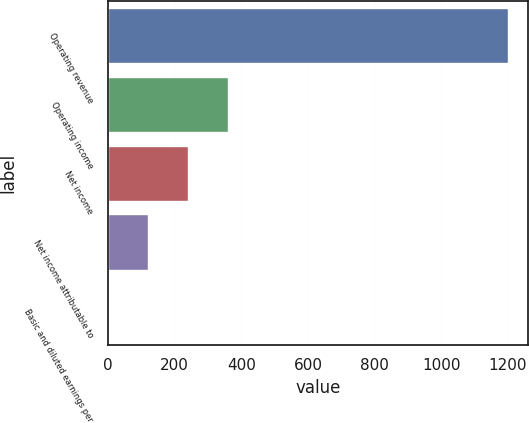Convert chart to OTSL. <chart><loc_0><loc_0><loc_500><loc_500><bar_chart><fcel>Operating revenue<fcel>Operating income<fcel>Net income<fcel>Net income attributable to<fcel>Basic and diluted earnings per<nl><fcel>1199.8<fcel>359.98<fcel>240.01<fcel>120.04<fcel>0.07<nl></chart> 